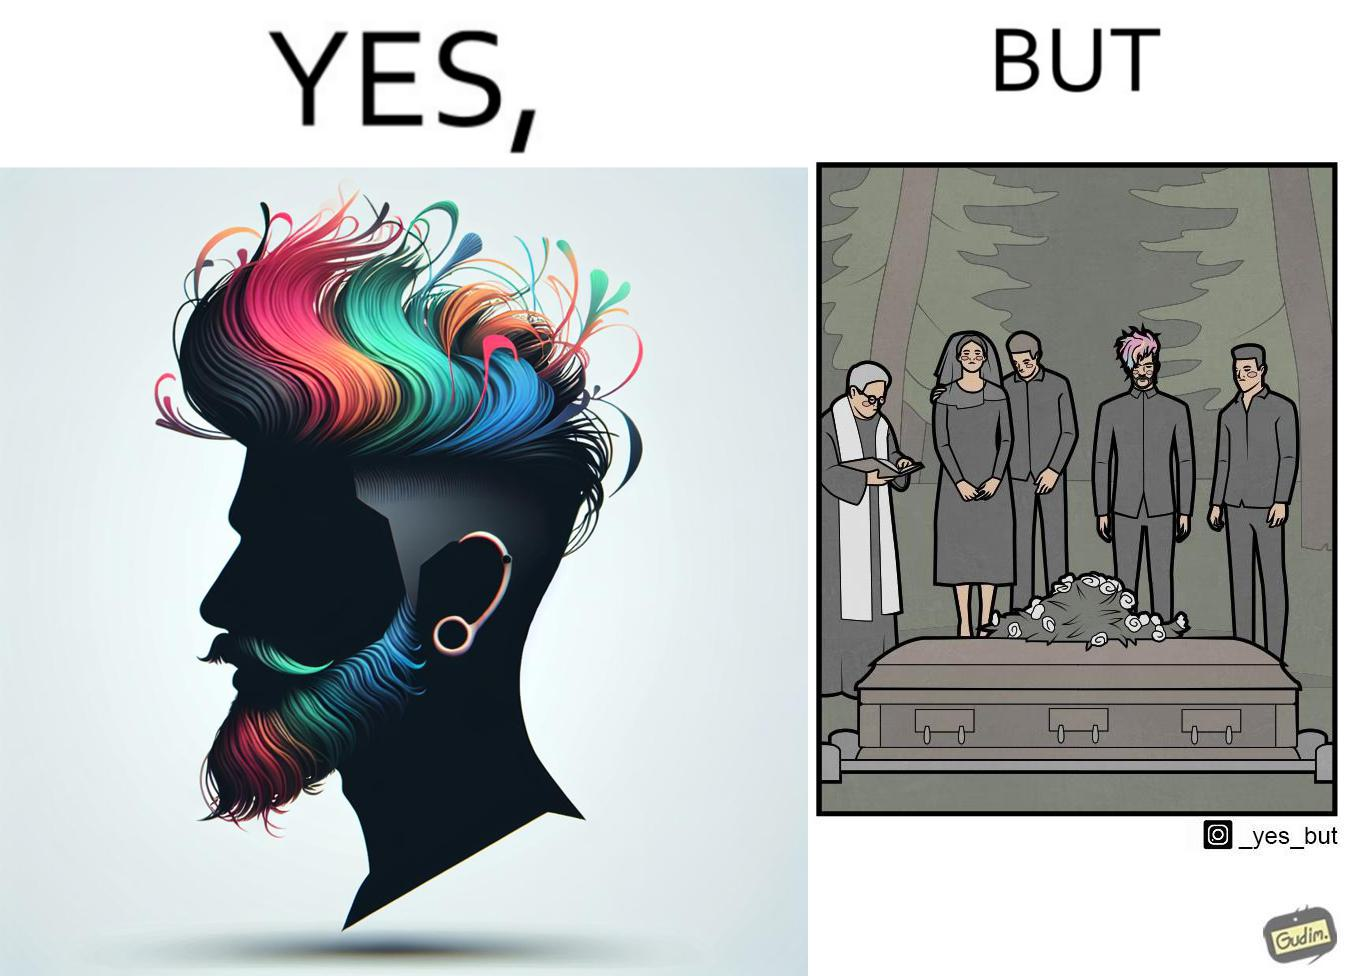Does this image contain satire or humor? Yes, this image is satirical. 